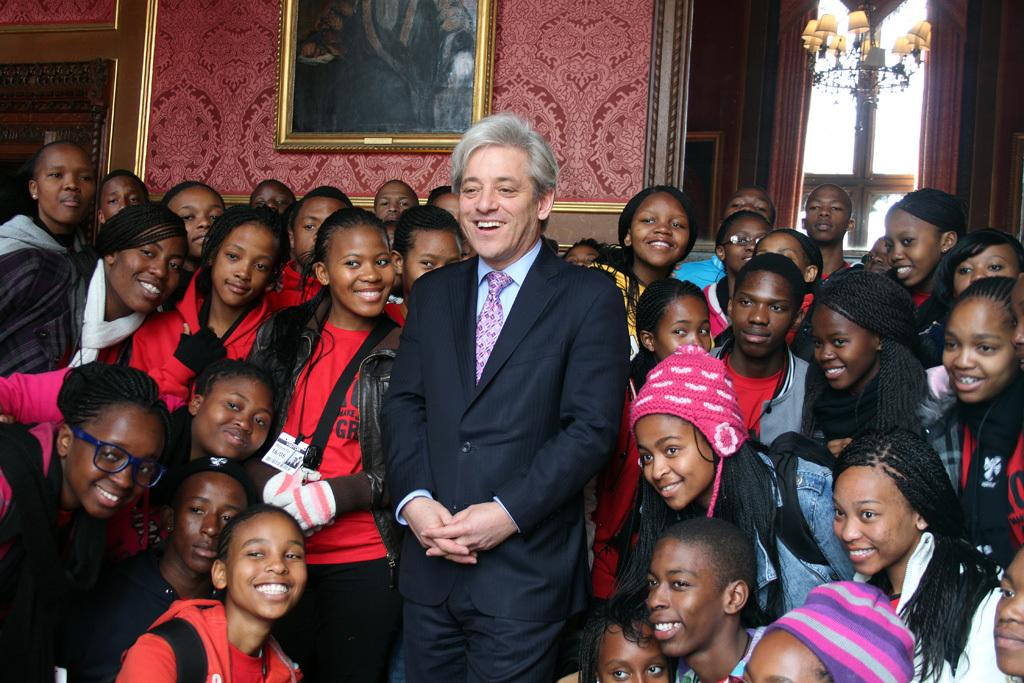How many people are in the image? There is a group of people in the image. What is the facial expression of the people in the image? The people are smiling. What can be seen in the background of the image? There is a frame, a wall, a pole, and lights in the background of the image. Can you see any twigs in the image? There are no twigs present in the image. What edge is visible in the image? There is no specific edge mentioned or visible in the image. 